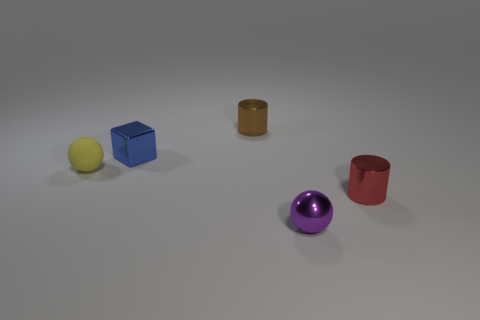Add 2 large matte spheres. How many objects exist? 7 Subtract all cubes. How many objects are left? 4 Subtract all blue shiny cubes. Subtract all cylinders. How many objects are left? 2 Add 2 tiny red objects. How many tiny red objects are left? 3 Add 2 purple matte spheres. How many purple matte spheres exist? 2 Subtract 0 red cubes. How many objects are left? 5 